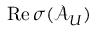<formula> <loc_0><loc_0><loc_500><loc_500>R e \, \sigma ( \mathcal { A } _ { U } )</formula> 